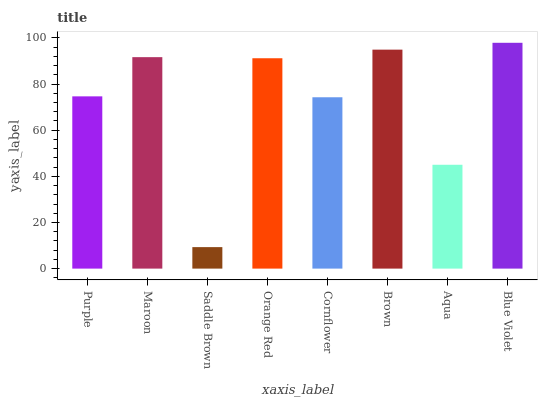Is Saddle Brown the minimum?
Answer yes or no. Yes. Is Blue Violet the maximum?
Answer yes or no. Yes. Is Maroon the minimum?
Answer yes or no. No. Is Maroon the maximum?
Answer yes or no. No. Is Maroon greater than Purple?
Answer yes or no. Yes. Is Purple less than Maroon?
Answer yes or no. Yes. Is Purple greater than Maroon?
Answer yes or no. No. Is Maroon less than Purple?
Answer yes or no. No. Is Orange Red the high median?
Answer yes or no. Yes. Is Purple the low median?
Answer yes or no. Yes. Is Blue Violet the high median?
Answer yes or no. No. Is Brown the low median?
Answer yes or no. No. 